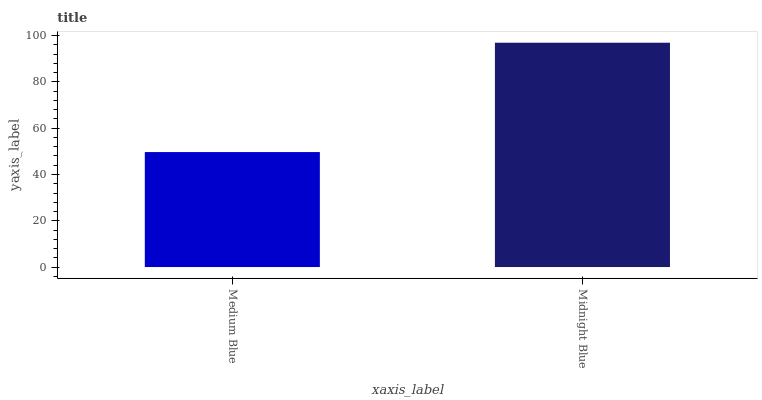Is Medium Blue the minimum?
Answer yes or no. Yes. Is Midnight Blue the maximum?
Answer yes or no. Yes. Is Midnight Blue the minimum?
Answer yes or no. No. Is Midnight Blue greater than Medium Blue?
Answer yes or no. Yes. Is Medium Blue less than Midnight Blue?
Answer yes or no. Yes. Is Medium Blue greater than Midnight Blue?
Answer yes or no. No. Is Midnight Blue less than Medium Blue?
Answer yes or no. No. Is Midnight Blue the high median?
Answer yes or no. Yes. Is Medium Blue the low median?
Answer yes or no. Yes. Is Medium Blue the high median?
Answer yes or no. No. Is Midnight Blue the low median?
Answer yes or no. No. 